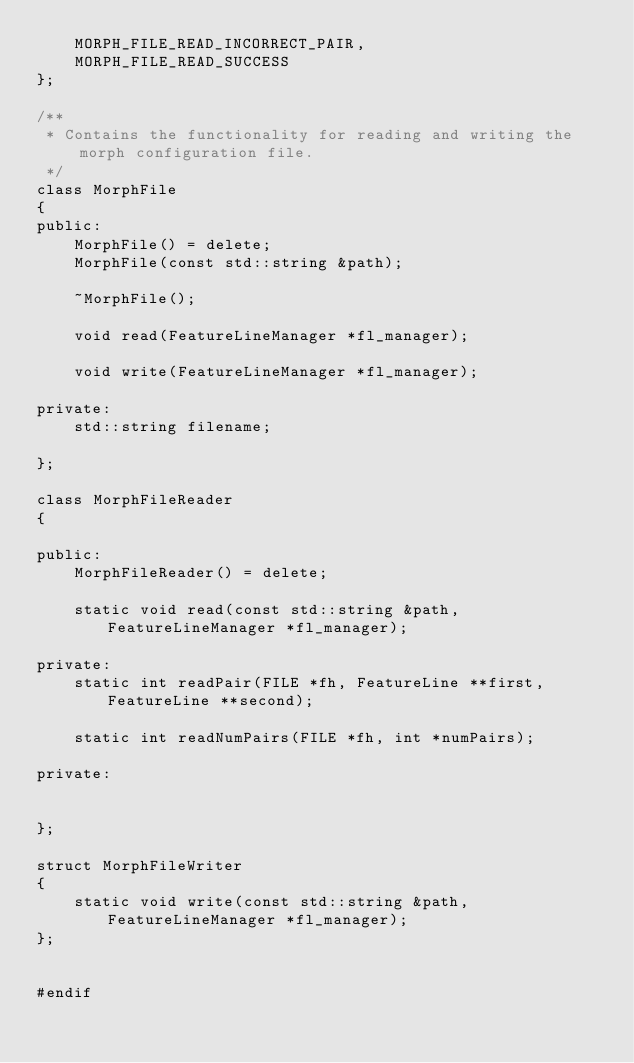<code> <loc_0><loc_0><loc_500><loc_500><_C++_>    MORPH_FILE_READ_INCORRECT_PAIR,
    MORPH_FILE_READ_SUCCESS
};

/**
 * Contains the functionality for reading and writing the morph configuration file.
 */
class MorphFile
{
public:
    MorphFile() = delete;
    MorphFile(const std::string &path);

    ~MorphFile();

    void read(FeatureLineManager *fl_manager);

    void write(FeatureLineManager *fl_manager);

private:
    std::string filename;

};

class MorphFileReader
{

public:
    MorphFileReader() = delete;

    static void read(const std::string &path, FeatureLineManager *fl_manager);

private:
    static int readPair(FILE *fh, FeatureLine **first, FeatureLine **second);

    static int readNumPairs(FILE *fh, int *numPairs);

private:


};

struct MorphFileWriter
{
    static void write(const std::string &path, FeatureLineManager *fl_manager);
};


#endif
</code> 